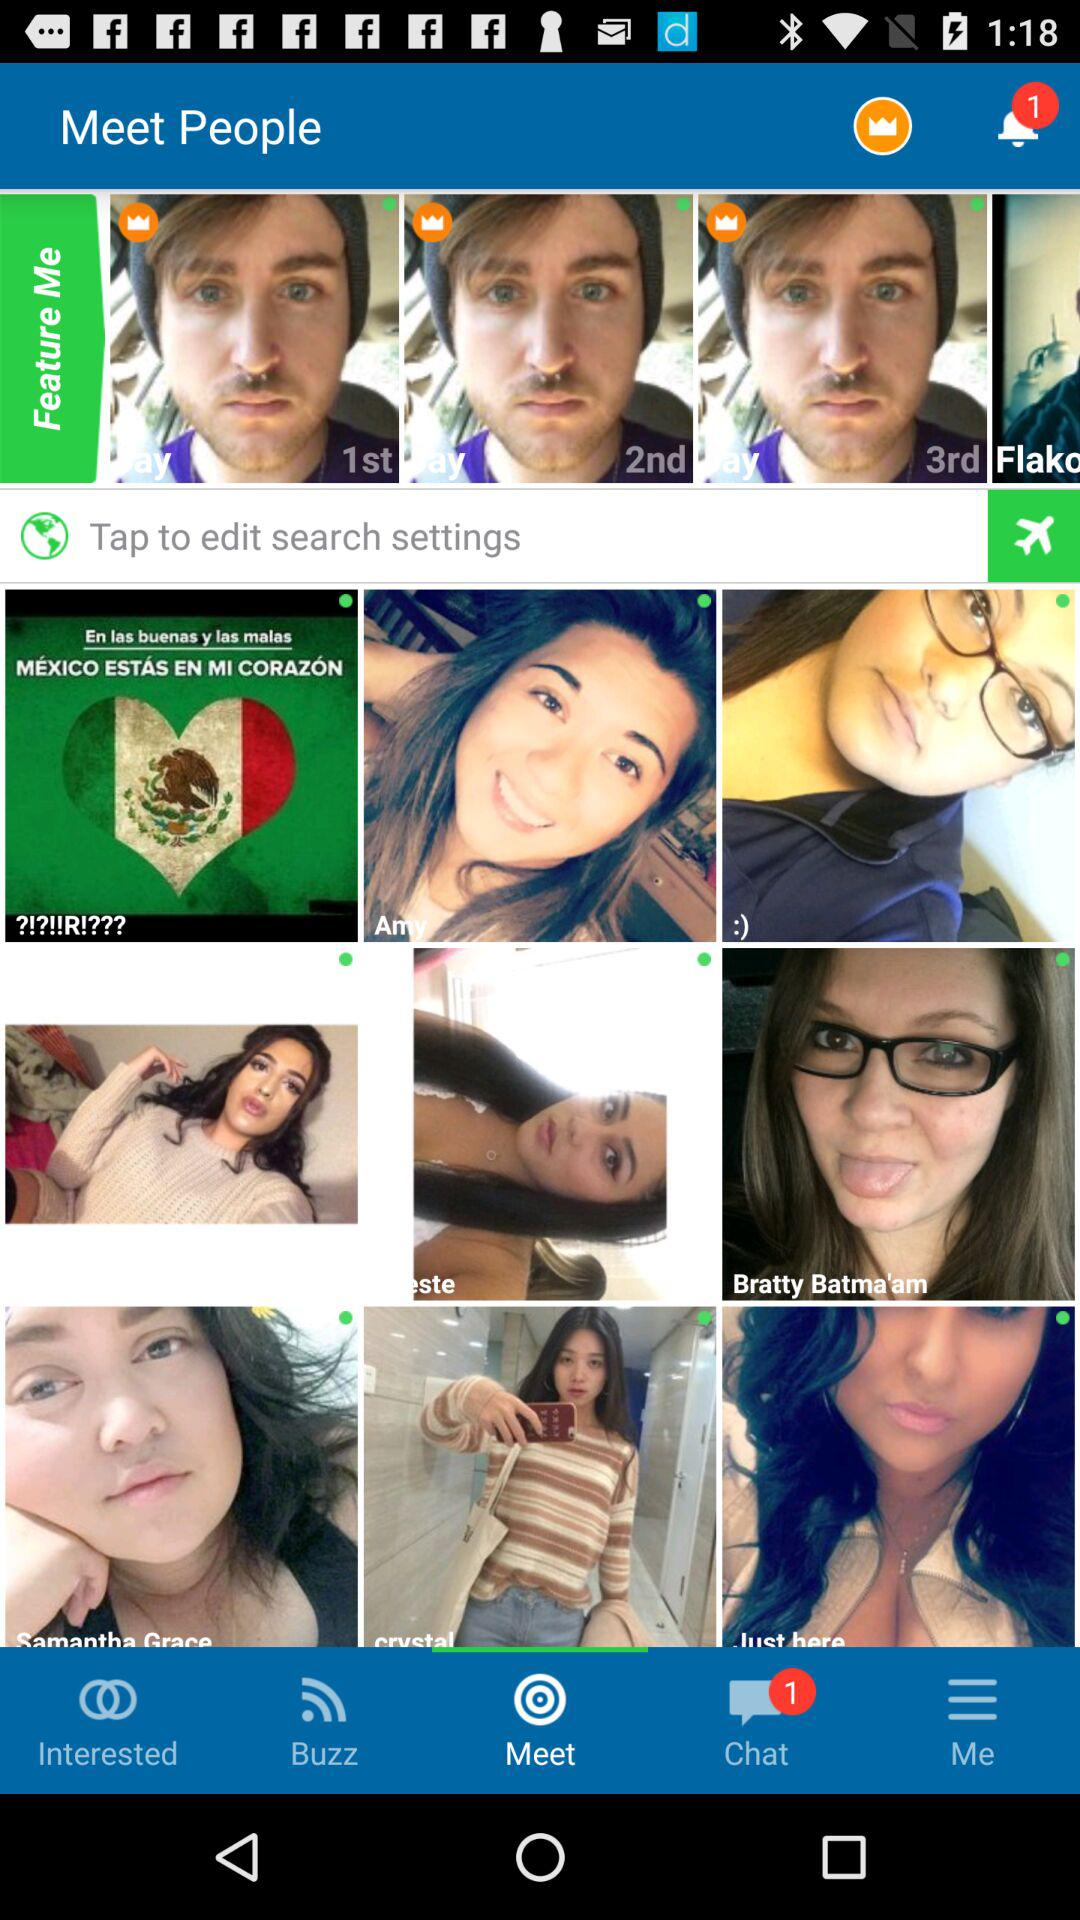How many chat notifications are there? There is 1 chat notification. 